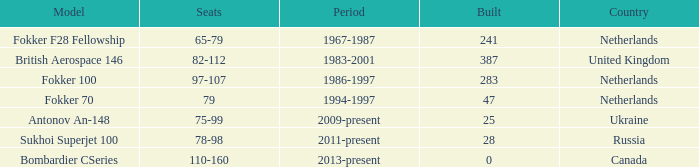How many cabins were built in the time between 1967-1987? 241.0. 